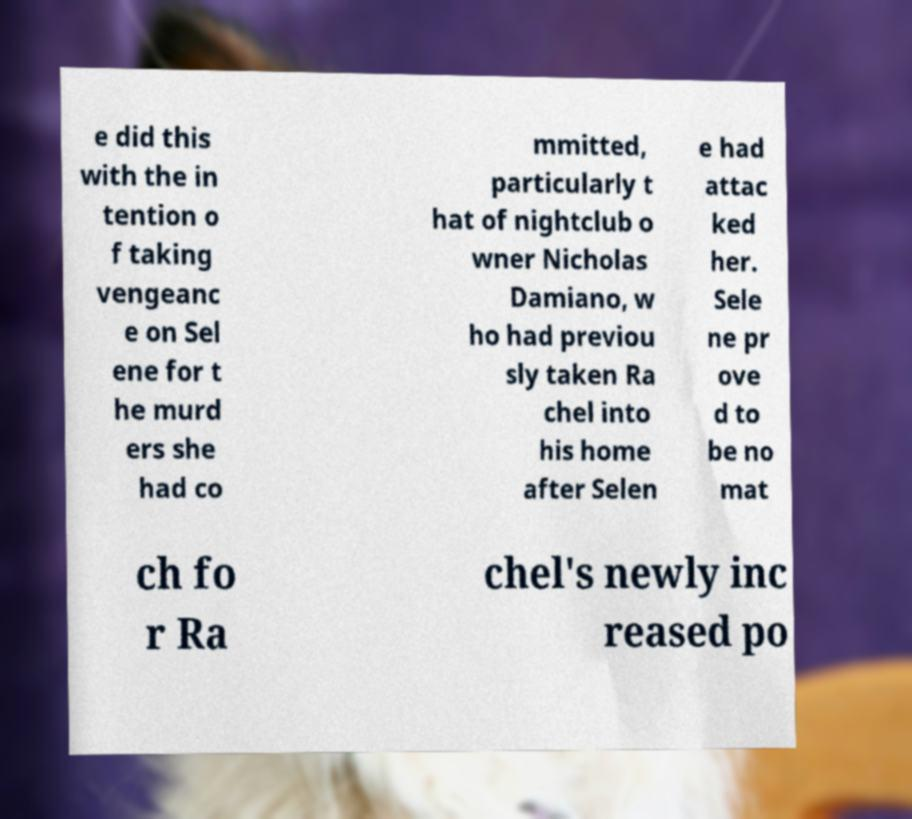Can you accurately transcribe the text from the provided image for me? e did this with the in tention o f taking vengeanc e on Sel ene for t he murd ers she had co mmitted, particularly t hat of nightclub o wner Nicholas Damiano, w ho had previou sly taken Ra chel into his home after Selen e had attac ked her. Sele ne pr ove d to be no mat ch fo r Ra chel's newly inc reased po 